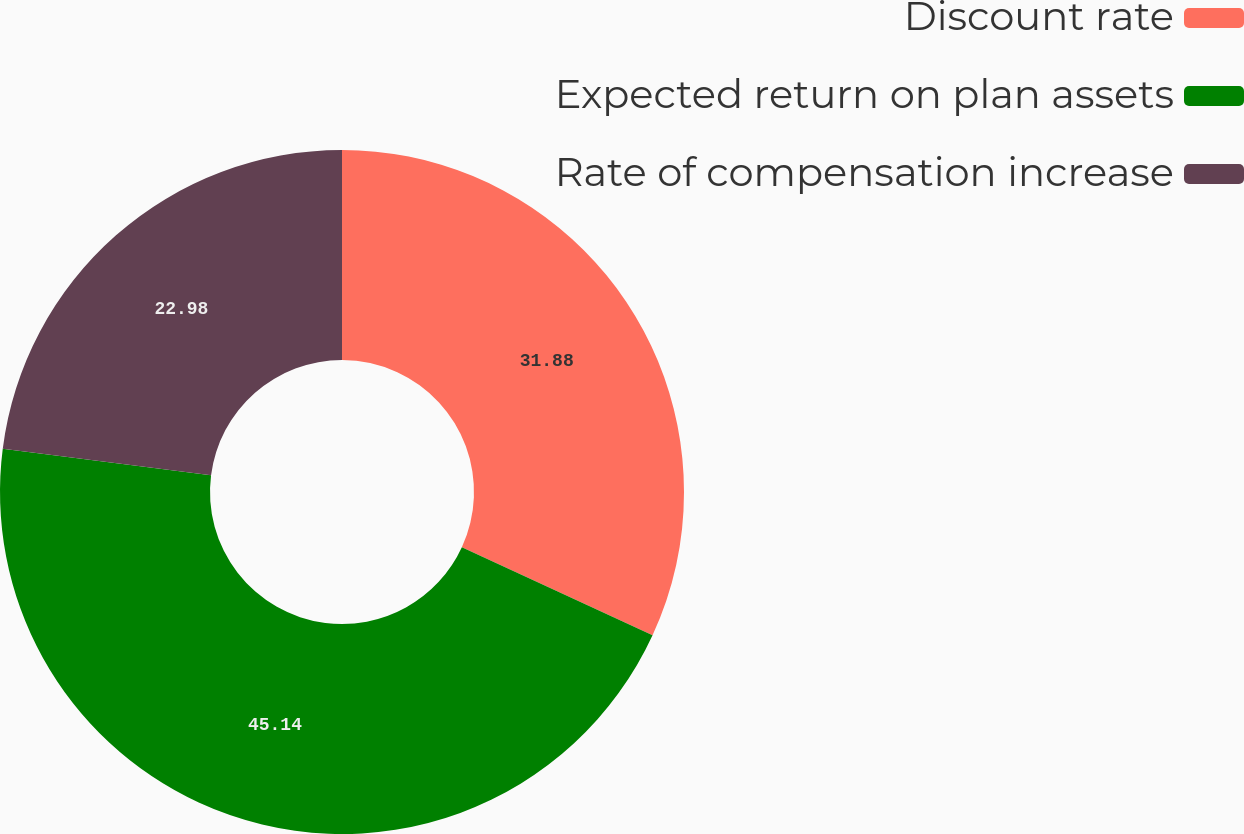Convert chart to OTSL. <chart><loc_0><loc_0><loc_500><loc_500><pie_chart><fcel>Discount rate<fcel>Expected return on plan assets<fcel>Rate of compensation increase<nl><fcel>31.88%<fcel>45.14%<fcel>22.98%<nl></chart> 